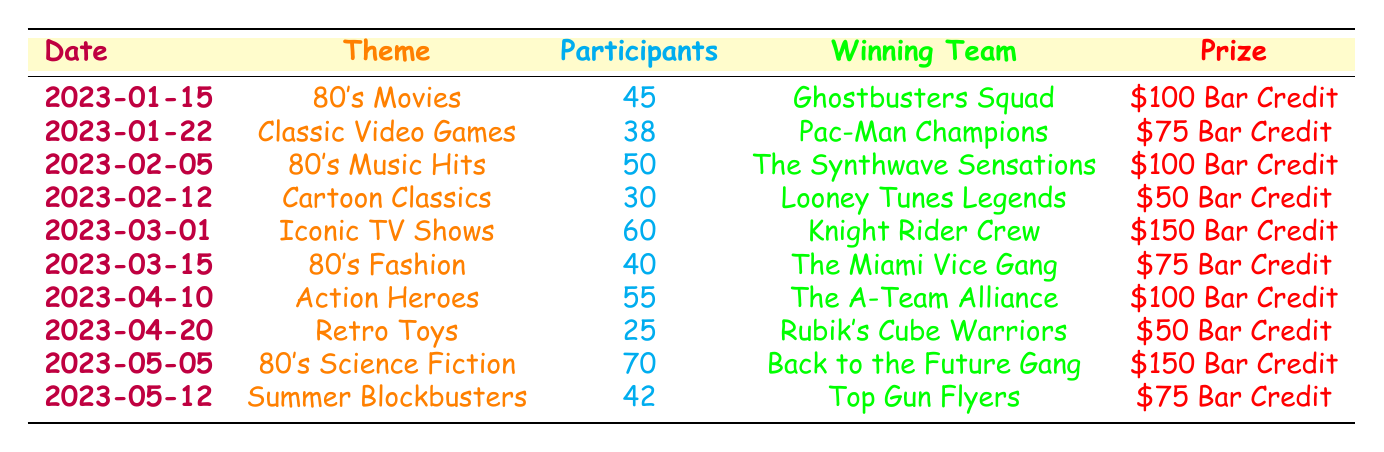What was the theme of the trivia night held on March 1, 2023? The table indicates that the trivia night on that date had the theme "Iconic TV Shows."
Answer: Iconic TV Shows Who won the trivia night on February 5, 2023? According to the table, the winning team for that night was "The Synthwave Sensations."
Answer: The Synthwave Sensations How many participants were there on trivia night for "80's Music Hits"? The table shows that there were 50 participants for the "80's Music Hits" trivia night on February 5, 2023.
Answer: 50 What was the prize for the winning team of the trivia night on April 20, 2023? The table states that the winning team received a prize of "$50 Bar Credit" for the trivia night themed "Retro Toys."
Answer: $50 Bar Credit Which trivia night had the highest number of participants? The table indicates that the trivia night on May 5, 2023, had the highest number of participants with 70.
Answer: 70 What is the difference in the number of participants between the trivia nights on February 12 and April 20, 2023? According to the table, there were 30 participants on February 12 and 25 on April 20. The difference is 30 - 25 = 5.
Answer: 5 What was the average number of participants across all trivia nights listed? There are 10 trivia nights listed with a total of participants equal to (45 + 38 + 50 + 30 + 60 + 40 + 55 + 25 + 70 + 42) =  450. The average is 450 / 10 = 45.
Answer: 45 Did the winning team for the trivia night with the theme "80's Fashion" receive a prize greater than $75 Bar Credit? The table shows that "The Miami Vice Gang" won the trivia night on March 15, 2023, with a prize of "$75 Bar Credit," which is not greater than $75.
Answer: No Which theme had the least number of participants, and how many were there? The trivia night themed "Retro Toys" on April 20, 2023, had the least number of participants, with a total of 25 participants.
Answer: Retro Toys, 25 How many trivia nights had a prize of $100 Bar Credit? The table lists three trivia nights with a prize of $100 Bar Credit: "80's Movies," "80's Music Hits," and "Action Heroes."
Answer: 3 